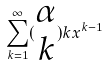<formula> <loc_0><loc_0><loc_500><loc_500>\sum _ { k = 1 } ^ { \infty } ( \begin{matrix} \alpha \\ k \end{matrix} ) k x ^ { k - 1 }</formula> 